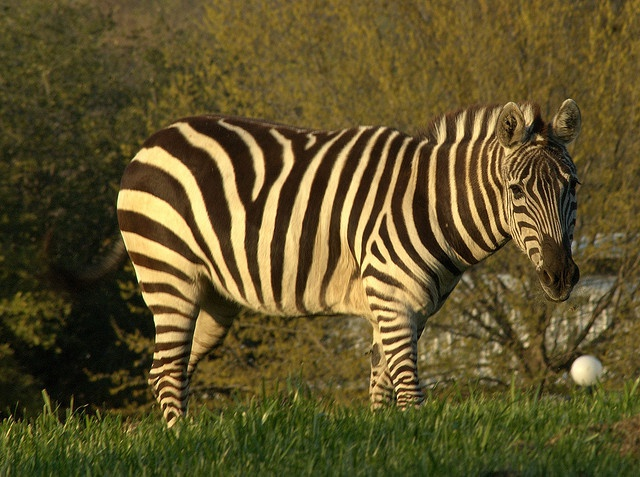Describe the objects in this image and their specific colors. I can see a zebra in olive, black, khaki, and maroon tones in this image. 